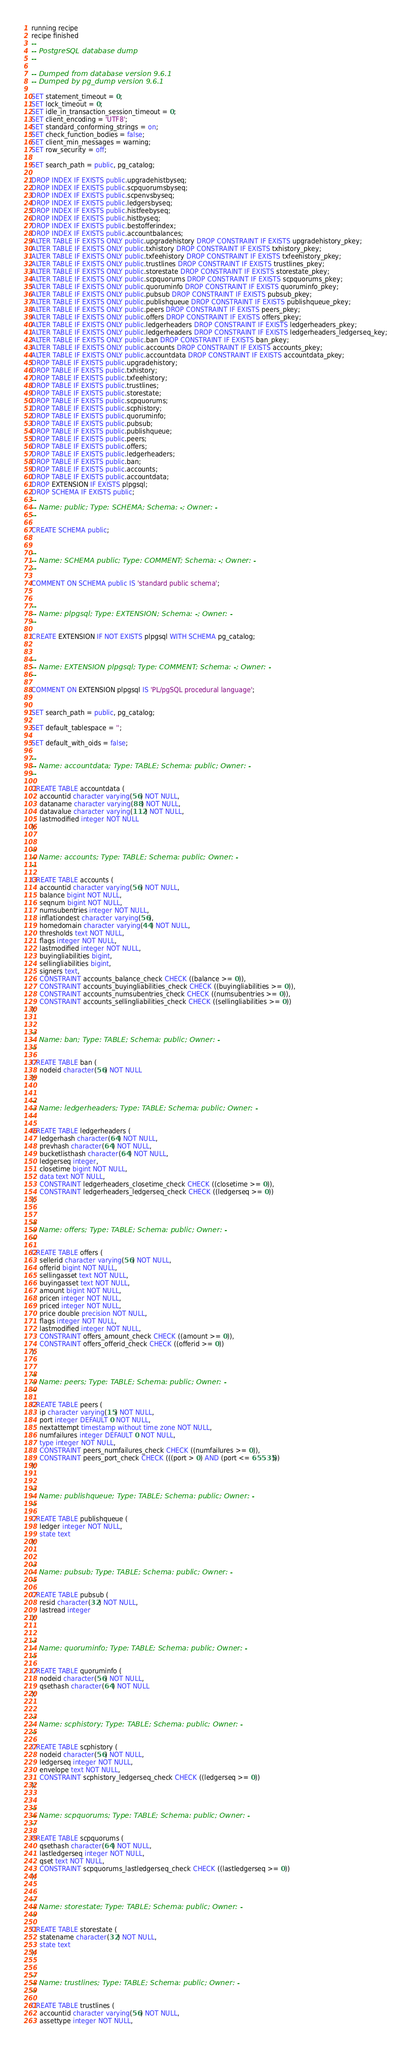<code> <loc_0><loc_0><loc_500><loc_500><_SQL_>running recipe
recipe finished
--
-- PostgreSQL database dump
--

-- Dumped from database version 9.6.1
-- Dumped by pg_dump version 9.6.1

SET statement_timeout = 0;
SET lock_timeout = 0;
SET idle_in_transaction_session_timeout = 0;
SET client_encoding = 'UTF8';
SET standard_conforming_strings = on;
SET check_function_bodies = false;
SET client_min_messages = warning;
SET row_security = off;

SET search_path = public, pg_catalog;

DROP INDEX IF EXISTS public.upgradehistbyseq;
DROP INDEX IF EXISTS public.scpquorumsbyseq;
DROP INDEX IF EXISTS public.scpenvsbyseq;
DROP INDEX IF EXISTS public.ledgersbyseq;
DROP INDEX IF EXISTS public.histfeebyseq;
DROP INDEX IF EXISTS public.histbyseq;
DROP INDEX IF EXISTS public.bestofferindex;
DROP INDEX IF EXISTS public.accountbalances;
ALTER TABLE IF EXISTS ONLY public.upgradehistory DROP CONSTRAINT IF EXISTS upgradehistory_pkey;
ALTER TABLE IF EXISTS ONLY public.txhistory DROP CONSTRAINT IF EXISTS txhistory_pkey;
ALTER TABLE IF EXISTS ONLY public.txfeehistory DROP CONSTRAINT IF EXISTS txfeehistory_pkey;
ALTER TABLE IF EXISTS ONLY public.trustlines DROP CONSTRAINT IF EXISTS trustlines_pkey;
ALTER TABLE IF EXISTS ONLY public.storestate DROP CONSTRAINT IF EXISTS storestate_pkey;
ALTER TABLE IF EXISTS ONLY public.scpquorums DROP CONSTRAINT IF EXISTS scpquorums_pkey;
ALTER TABLE IF EXISTS ONLY public.quoruminfo DROP CONSTRAINT IF EXISTS quoruminfo_pkey;
ALTER TABLE IF EXISTS ONLY public.pubsub DROP CONSTRAINT IF EXISTS pubsub_pkey;
ALTER TABLE IF EXISTS ONLY public.publishqueue DROP CONSTRAINT IF EXISTS publishqueue_pkey;
ALTER TABLE IF EXISTS ONLY public.peers DROP CONSTRAINT IF EXISTS peers_pkey;
ALTER TABLE IF EXISTS ONLY public.offers DROP CONSTRAINT IF EXISTS offers_pkey;
ALTER TABLE IF EXISTS ONLY public.ledgerheaders DROP CONSTRAINT IF EXISTS ledgerheaders_pkey;
ALTER TABLE IF EXISTS ONLY public.ledgerheaders DROP CONSTRAINT IF EXISTS ledgerheaders_ledgerseq_key;
ALTER TABLE IF EXISTS ONLY public.ban DROP CONSTRAINT IF EXISTS ban_pkey;
ALTER TABLE IF EXISTS ONLY public.accounts DROP CONSTRAINT IF EXISTS accounts_pkey;
ALTER TABLE IF EXISTS ONLY public.accountdata DROP CONSTRAINT IF EXISTS accountdata_pkey;
DROP TABLE IF EXISTS public.upgradehistory;
DROP TABLE IF EXISTS public.txhistory;
DROP TABLE IF EXISTS public.txfeehistory;
DROP TABLE IF EXISTS public.trustlines;
DROP TABLE IF EXISTS public.storestate;
DROP TABLE IF EXISTS public.scpquorums;
DROP TABLE IF EXISTS public.scphistory;
DROP TABLE IF EXISTS public.quoruminfo;
DROP TABLE IF EXISTS public.pubsub;
DROP TABLE IF EXISTS public.publishqueue;
DROP TABLE IF EXISTS public.peers;
DROP TABLE IF EXISTS public.offers;
DROP TABLE IF EXISTS public.ledgerheaders;
DROP TABLE IF EXISTS public.ban;
DROP TABLE IF EXISTS public.accounts;
DROP TABLE IF EXISTS public.accountdata;
DROP EXTENSION IF EXISTS plpgsql;
DROP SCHEMA IF EXISTS public;
--
-- Name: public; Type: SCHEMA; Schema: -; Owner: -
--

CREATE SCHEMA public;


--
-- Name: SCHEMA public; Type: COMMENT; Schema: -; Owner: -
--

COMMENT ON SCHEMA public IS 'standard public schema';


--
-- Name: plpgsql; Type: EXTENSION; Schema: -; Owner: -
--

CREATE EXTENSION IF NOT EXISTS plpgsql WITH SCHEMA pg_catalog;


--
-- Name: EXTENSION plpgsql; Type: COMMENT; Schema: -; Owner: -
--

COMMENT ON EXTENSION plpgsql IS 'PL/pgSQL procedural language';


SET search_path = public, pg_catalog;

SET default_tablespace = '';

SET default_with_oids = false;

--
-- Name: accountdata; Type: TABLE; Schema: public; Owner: -
--

CREATE TABLE accountdata (
    accountid character varying(56) NOT NULL,
    dataname character varying(88) NOT NULL,
    datavalue character varying(112) NOT NULL,
    lastmodified integer NOT NULL
);


--
-- Name: accounts; Type: TABLE; Schema: public; Owner: -
--

CREATE TABLE accounts (
    accountid character varying(56) NOT NULL,
    balance bigint NOT NULL,
    seqnum bigint NOT NULL,
    numsubentries integer NOT NULL,
    inflationdest character varying(56),
    homedomain character varying(44) NOT NULL,
    thresholds text NOT NULL,
    flags integer NOT NULL,
    lastmodified integer NOT NULL,
    buyingliabilities bigint,
    sellingliabilities bigint,
    signers text,
    CONSTRAINT accounts_balance_check CHECK ((balance >= 0)),
    CONSTRAINT accounts_buyingliabilities_check CHECK ((buyingliabilities >= 0)),
    CONSTRAINT accounts_numsubentries_check CHECK ((numsubentries >= 0)),
    CONSTRAINT accounts_sellingliabilities_check CHECK ((sellingliabilities >= 0))
);


--
-- Name: ban; Type: TABLE; Schema: public; Owner: -
--

CREATE TABLE ban (
    nodeid character(56) NOT NULL
);


--
-- Name: ledgerheaders; Type: TABLE; Schema: public; Owner: -
--

CREATE TABLE ledgerheaders (
    ledgerhash character(64) NOT NULL,
    prevhash character(64) NOT NULL,
    bucketlisthash character(64) NOT NULL,
    ledgerseq integer,
    closetime bigint NOT NULL,
    data text NOT NULL,
    CONSTRAINT ledgerheaders_closetime_check CHECK ((closetime >= 0)),
    CONSTRAINT ledgerheaders_ledgerseq_check CHECK ((ledgerseq >= 0))
);


--
-- Name: offers; Type: TABLE; Schema: public; Owner: -
--

CREATE TABLE offers (
    sellerid character varying(56) NOT NULL,
    offerid bigint NOT NULL,
    sellingasset text NOT NULL,
    buyingasset text NOT NULL,
    amount bigint NOT NULL,
    pricen integer NOT NULL,
    priced integer NOT NULL,
    price double precision NOT NULL,
    flags integer NOT NULL,
    lastmodified integer NOT NULL,
    CONSTRAINT offers_amount_check CHECK ((amount >= 0)),
    CONSTRAINT offers_offerid_check CHECK ((offerid >= 0))
);


--
-- Name: peers; Type: TABLE; Schema: public; Owner: -
--

CREATE TABLE peers (
    ip character varying(15) NOT NULL,
    port integer DEFAULT 0 NOT NULL,
    nextattempt timestamp without time zone NOT NULL,
    numfailures integer DEFAULT 0 NOT NULL,
    type integer NOT NULL,
    CONSTRAINT peers_numfailures_check CHECK ((numfailures >= 0)),
    CONSTRAINT peers_port_check CHECK (((port > 0) AND (port <= 65535)))
);


--
-- Name: publishqueue; Type: TABLE; Schema: public; Owner: -
--

CREATE TABLE publishqueue (
    ledger integer NOT NULL,
    state text
);


--
-- Name: pubsub; Type: TABLE; Schema: public; Owner: -
--

CREATE TABLE pubsub (
    resid character(32) NOT NULL,
    lastread integer
);


--
-- Name: quoruminfo; Type: TABLE; Schema: public; Owner: -
--

CREATE TABLE quoruminfo (
    nodeid character(56) NOT NULL,
    qsethash character(64) NOT NULL
);


--
-- Name: scphistory; Type: TABLE; Schema: public; Owner: -
--

CREATE TABLE scphistory (
    nodeid character(56) NOT NULL,
    ledgerseq integer NOT NULL,
    envelope text NOT NULL,
    CONSTRAINT scphistory_ledgerseq_check CHECK ((ledgerseq >= 0))
);


--
-- Name: scpquorums; Type: TABLE; Schema: public; Owner: -
--

CREATE TABLE scpquorums (
    qsethash character(64) NOT NULL,
    lastledgerseq integer NOT NULL,
    qset text NOT NULL,
    CONSTRAINT scpquorums_lastledgerseq_check CHECK ((lastledgerseq >= 0))
);


--
-- Name: storestate; Type: TABLE; Schema: public; Owner: -
--

CREATE TABLE storestate (
    statename character(32) NOT NULL,
    state text
);


--
-- Name: trustlines; Type: TABLE; Schema: public; Owner: -
--

CREATE TABLE trustlines (
    accountid character varying(56) NOT NULL,
    assettype integer NOT NULL,</code> 